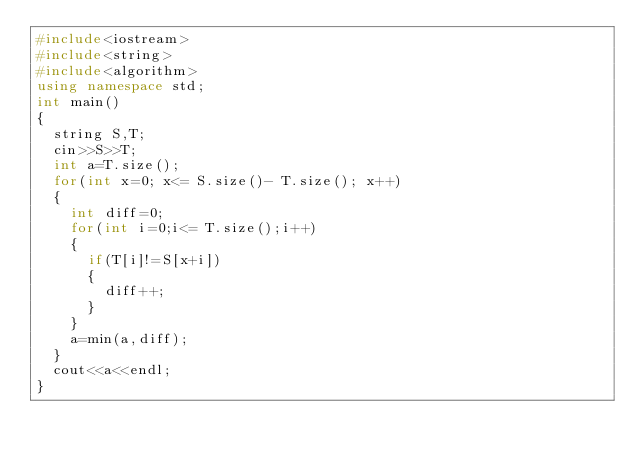Convert code to text. <code><loc_0><loc_0><loc_500><loc_500><_C++_>#include<iostream>
#include<string>
#include<algorithm>
using namespace std;
int main()
{
  string S,T;
  cin>>S>>T;
  int a=T.size();
  for(int x=0; x<= S.size()- T.size(); x++)
  { 
    int diff=0;
    for(int i=0;i<= T.size();i++)
    {
      if(T[i]!=S[x+i])
      {
        diff++;
      }
    }
    a=min(a,diff);
  }
  cout<<a<<endl;
}
</code> 